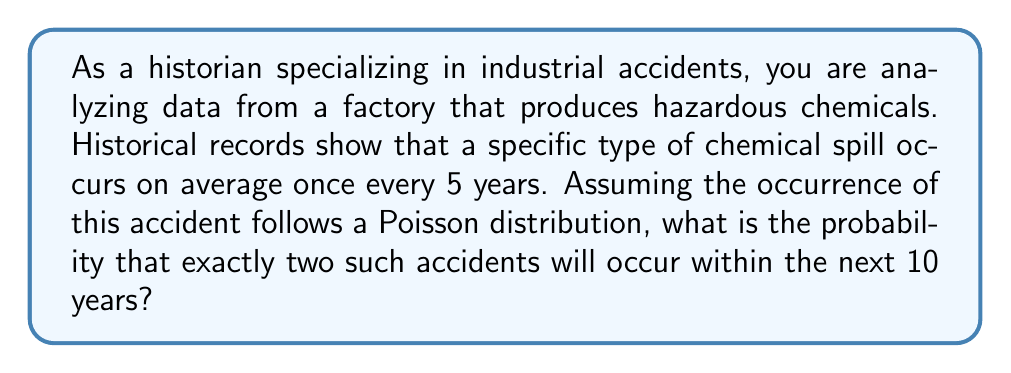Give your solution to this math problem. To solve this problem, we'll use the Poisson distribution, which is appropriate for modeling the number of events occurring in a fixed interval of time when these events happen with a known average rate.

1. Let's define our variables:
   $\lambda$ = average number of events in the given time period
   $k$ = number of events we're interested in
   $t$ = time period we're considering
   $\mu$ = average rate of events

2. We know that on average, the accident occurs once every 5 years. So for a 10-year period:
   $\lambda = \frac{10\text{ years}}{5\text{ years/event}} = 2$ events

3. The Poisson probability mass function is:

   $P(X = k) = \frac{e^{-\lambda}\lambda^k}{k!}$

4. We want the probability of exactly 2 events $(k = 2)$ in 10 years:

   $P(X = 2) = \frac{e^{-2}2^2}{2!}$

5. Let's calculate this step by step:
   
   $P(X = 2) = \frac{e^{-2} \cdot 4}{2}$
   
   $= \frac{e^{-2} \cdot 4}{2}$
   
   $= 2e^{-2}$
   
   $\approx 2 \cdot 0.1353$
   
   $\approx 0.2707$

Therefore, the probability of exactly two such accidents occurring within the next 10 years is approximately 0.2707 or 27.07%.
Answer: $P(X = 2) = 2e^{-2} \approx 0.2707$ or $27.07\%$ 